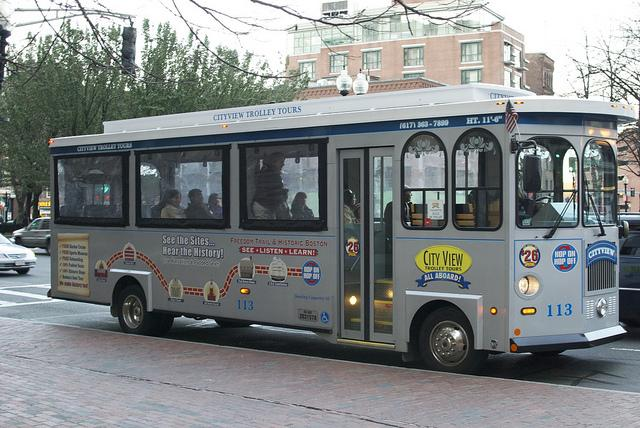What is the bus primarily used for? Please explain your reasoning. tours. The bus says city view on it. it is a tour bus. 